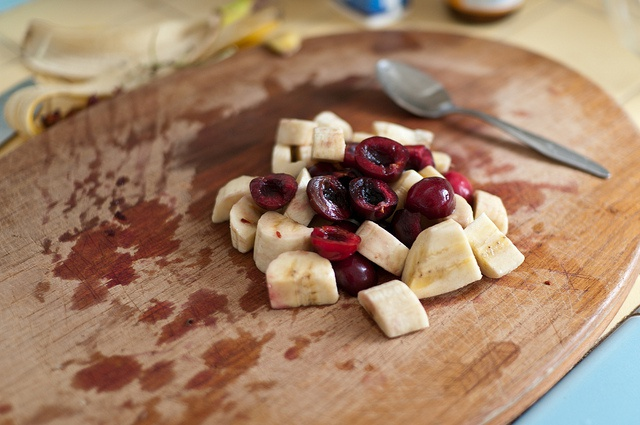Describe the objects in this image and their specific colors. I can see banana in lightblue, tan, and gray tones, banana in lightblue, beige, and tan tones, and spoon in lightblue, darkgray, and gray tones in this image. 